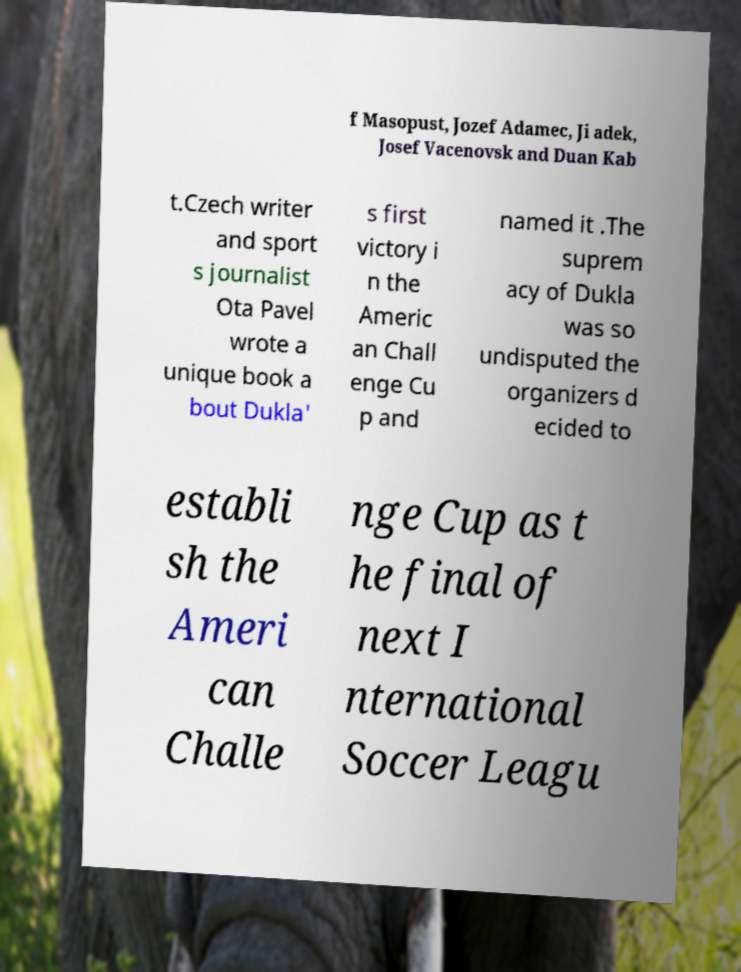Could you extract and type out the text from this image? f Masopust, Jozef Adamec, Ji adek, Josef Vacenovsk and Duan Kab t.Czech writer and sport s journalist Ota Pavel wrote a unique book a bout Dukla' s first victory i n the Americ an Chall enge Cu p and named it .The suprem acy of Dukla was so undisputed the organizers d ecided to establi sh the Ameri can Challe nge Cup as t he final of next I nternational Soccer Leagu 